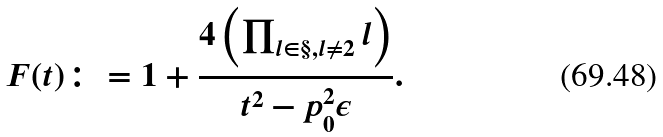Convert formula to latex. <formula><loc_0><loc_0><loc_500><loc_500>\ F ( t ) \colon = 1 + \frac { 4 \left ( \prod _ { l \in \S , l \ne 2 } l \right ) } { t ^ { 2 } - p _ { 0 } ^ { 2 } \epsilon } .</formula> 